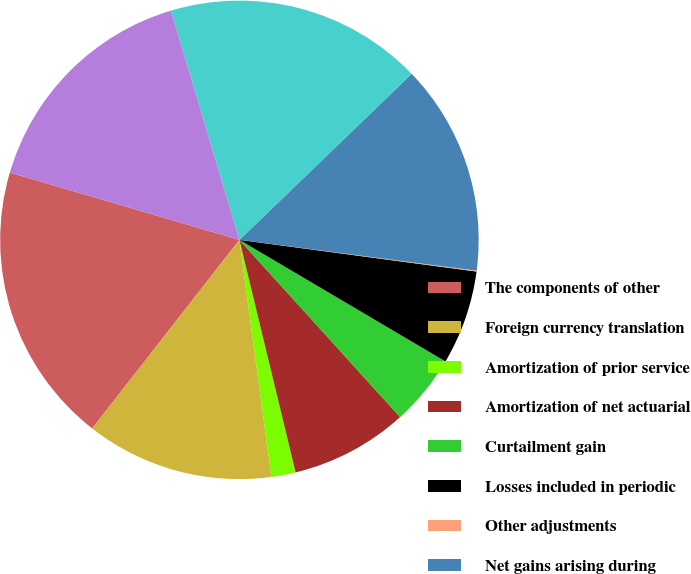<chart> <loc_0><loc_0><loc_500><loc_500><pie_chart><fcel>The components of other<fcel>Foreign currency translation<fcel>Amortization of prior service<fcel>Amortization of net actuarial<fcel>Curtailment gain<fcel>Losses included in periodic<fcel>Other adjustments<fcel>Net gains arising during<fcel>Pension/post-retirement plans<fcel>Other comprehensive income<nl><fcel>18.99%<fcel>12.68%<fcel>1.64%<fcel>7.95%<fcel>4.79%<fcel>6.37%<fcel>0.06%<fcel>14.26%<fcel>17.41%<fcel>15.84%<nl></chart> 